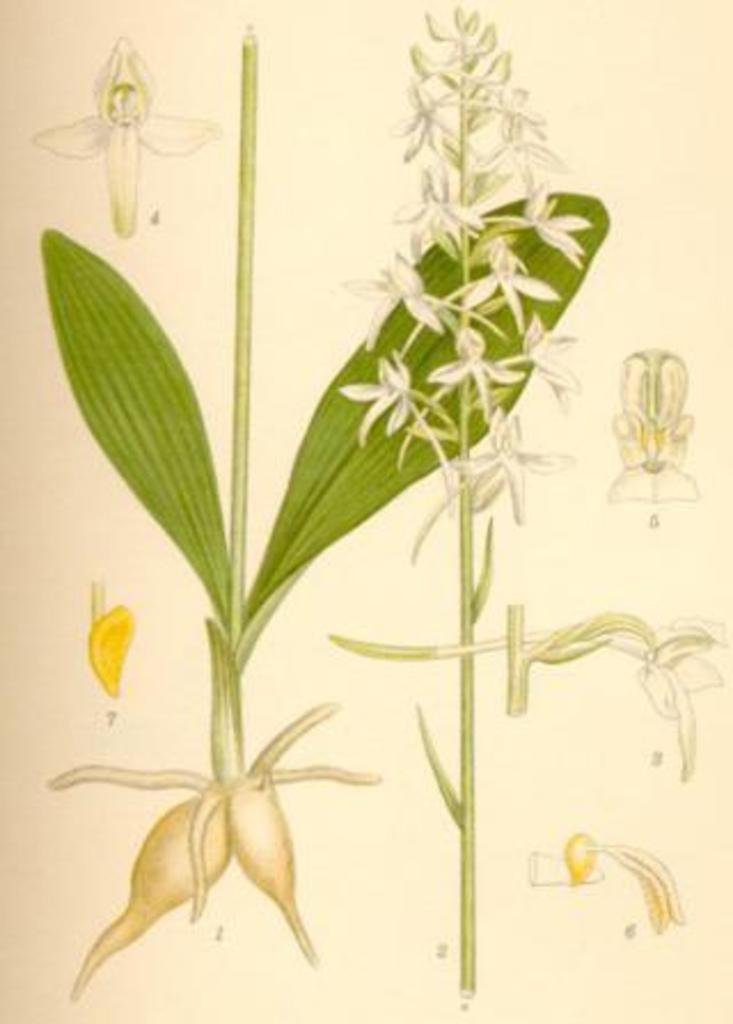What types of plants are depicted on the page? The page contains images of flowers and leaves. Can you describe the specific elements of the plant images on the page? The images on the page depict flowers and leaves, which are common parts of plants. How many sisters are shown playing the drum in the image? There are no sisters or drums present in the image; it only contains images of flowers and leaves. Can you tell me how many lizards are visible in the image? There are no lizards present in the image; it only contains images of flowers and leaves. 